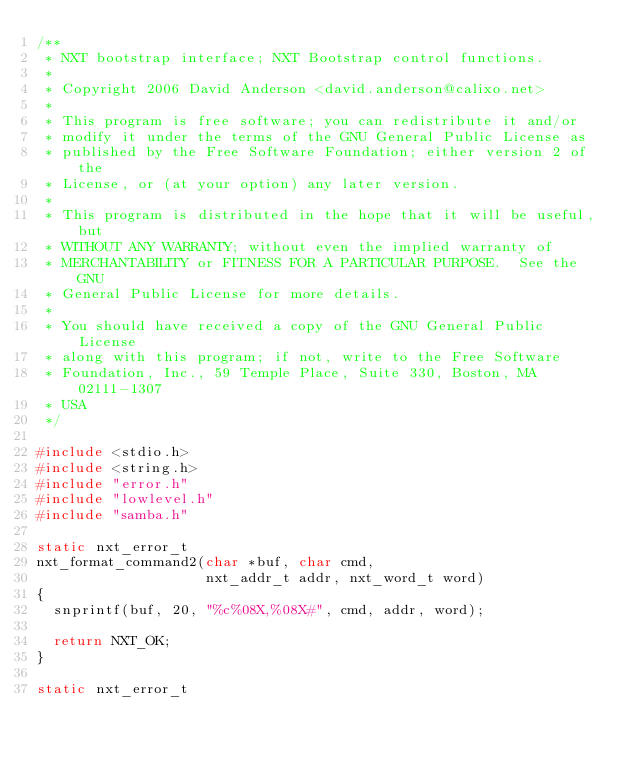<code> <loc_0><loc_0><loc_500><loc_500><_C_>/**
 * NXT bootstrap interface; NXT Bootstrap control functions.
 *
 * Copyright 2006 David Anderson <david.anderson@calixo.net>
 *
 * This program is free software; you can redistribute it and/or
 * modify it under the terms of the GNU General Public License as
 * published by the Free Software Foundation; either version 2 of the
 * License, or (at your option) any later version.
 *
 * This program is distributed in the hope that it will be useful, but
 * WITHOUT ANY WARRANTY; without even the implied warranty of
 * MERCHANTABILITY or FITNESS FOR A PARTICULAR PURPOSE.  See the GNU
 * General Public License for more details.
 *
 * You should have received a copy of the GNU General Public License
 * along with this program; if not, write to the Free Software
 * Foundation, Inc., 59 Temple Place, Suite 330, Boston, MA 02111-1307
 * USA
 */

#include <stdio.h>
#include <string.h>
#include "error.h"
#include "lowlevel.h"
#include "samba.h"

static nxt_error_t
nxt_format_command2(char *buf, char cmd,
                    nxt_addr_t addr, nxt_word_t word)
{
  snprintf(buf, 20, "%c%08X,%08X#", cmd, addr, word);

  return NXT_OK;
}

static nxt_error_t</code> 